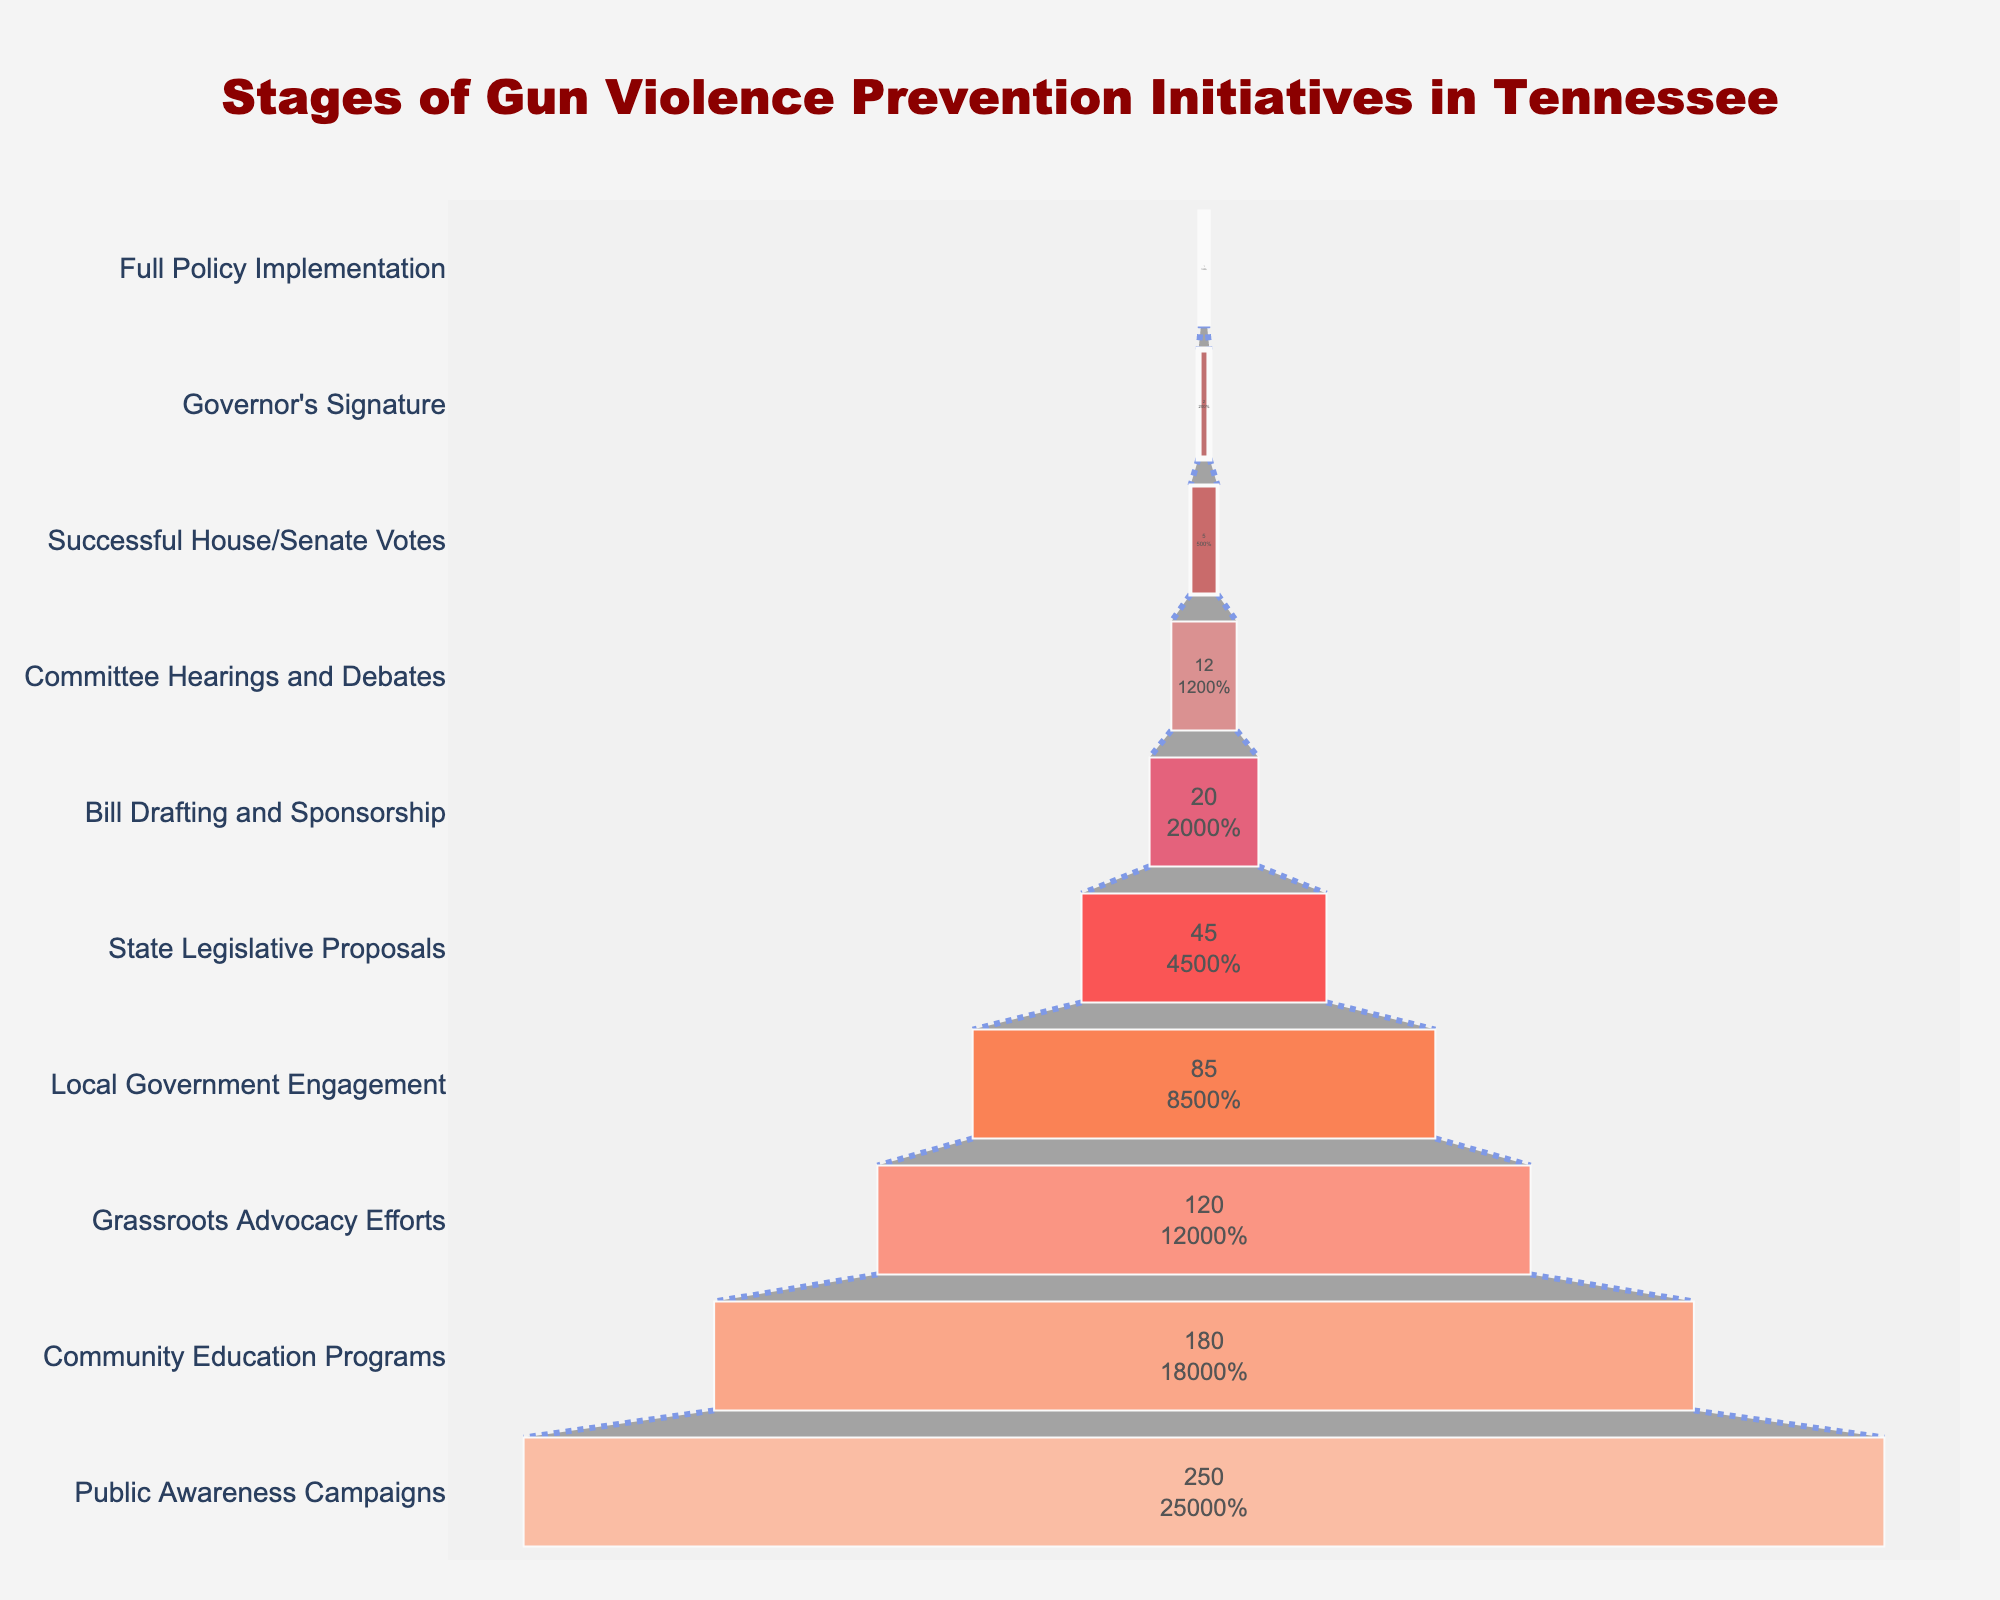What is the title of the funnel chart? The top of the funnel chart displays the title in a larger font than the rest of the text.
Answer: Stages of Gun Violence Prevention Initiatives in Tennessee What is the stage with the highest number of initiatives? The funnel chart starts with the highest number of initiatives at the top. The top-most stage represents the stage with the highest number.
Answer: Public Awareness Campaigns How many initiatives advance from Community Education Programs to Grassroots Advocacy Efforts? You need to find the number of initiatives at the Community Education Programs stage and the number at the Grassroots Advocacy Efforts stage, then subtract the latter from the former. It means 180 - 120.
Answer: 60 Which stage shows the largest drop in the number of initiatives from the previous stage? To determine the largest drop, calculate the difference in the number of initiatives between each consecutive stage and identify the maximum value. The largest drop is between Public Awareness Campaigns to Community Education Programs (250 - 180 = 70 initiatives).
Answer: Public Awareness Campaigns to Community Education Programs What percent of initiatives that started as Public Awareness Campaigns reach the Full Policy Implementation stage? To find the percentage, divide the number of initiatives that reach Full Policy Implementation (1) by the number of initial Public Awareness Campaigns (250), then multiply by 100. So, (1/250) * 100.
Answer: 0.4% How many stages are there in total in the funnel chart? Count the total number of distinct stages listed in the funnel chart.
Answer: 10 Which stage comes immediately before Successful House/Senate Votes? Traverse the funnel from the bottom to identify the stage listed immediately above Successful House/Senate Votes.
Answer: Committee Hearings and Debates How many more initiatives are there in Local Government Engagement than in Bill Drafting and Sponsorship? Subtract the number of Bill Drafting and Sponsorship initiatives (20) from the number of Local Government Engagement initiatives (85). So, 85 - 20.
Answer: 65 What color are the Governor's Signature and Full Policy Implementation stages? Identify the color from the funnel chart for the last two stages at the bottom. The stages have light shades of red and pink.
Answer: Light shades of red and pink Which two consecutive stages have the least number of initiatives drop? Identify consecutive stages where the decrease in numbers between them is the smallest. Bill Drafting and Sponsorship (20) to Committee Hearings and Debates (12) has a drop of 8 initiatives.
Answer: Bill Drafting and Sponsorship to Committee Hearings and Debates 